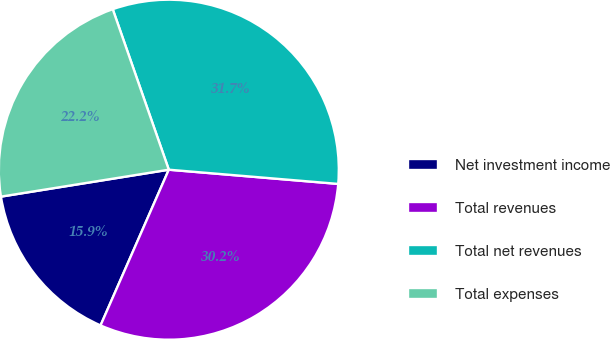<chart> <loc_0><loc_0><loc_500><loc_500><pie_chart><fcel>Net investment income<fcel>Total revenues<fcel>Total net revenues<fcel>Total expenses<nl><fcel>15.89%<fcel>30.24%<fcel>31.68%<fcel>22.18%<nl></chart> 